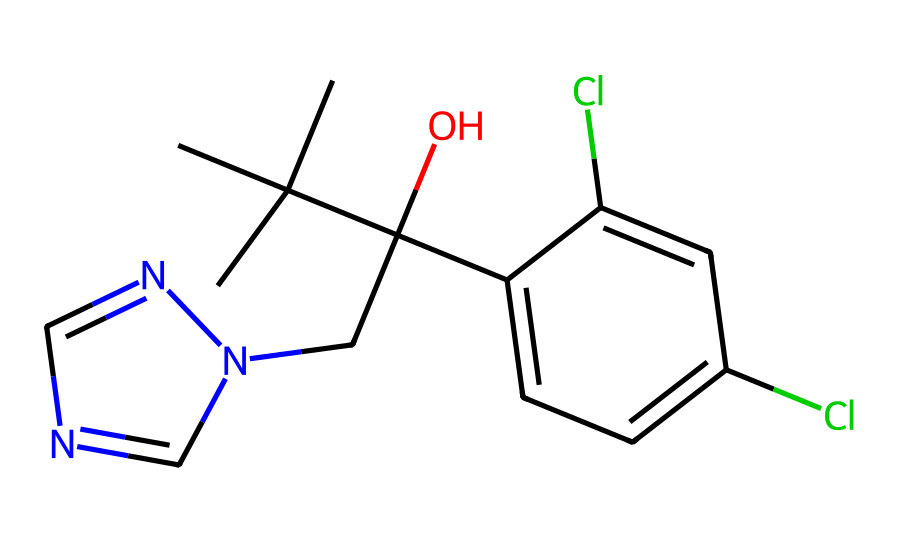What is the main functional group in this compound? In the provided chemical structure, the alcohol group (-OH) attached to the carbon chain is the primary functional group identified within the molecule, which indicates its role in chemical reactivity.
Answer: alcohol How many chlorine atoms are present in the structure? By examining the chemical structure, there are two distinct chlorine (Cl) substituents attached to the aromatic ring, which can be counted directly from the representation.
Answer: two What is the total number of nitrogen atoms in the chemical? Observing the structure shows there are two nitrogen (N) atoms existing within the five-membered ring, specifically contributing to the overall heterocyclic framework of the compound, allowing for proper counting.
Answer: two Is this compound likely to be water-soluble? The presence of both the hydroxyl (-OH) group and the nitrogen atoms generally suggests that the compound could form hydrogen bonds with water, indicating a likelihood of water solubility.
Answer: likely Which ring system is present in this chemical? The compound contains a five-membered ring that consists of nitrogen atoms, which characterizes it as a nitrogen-containing heterocycle. This specific structure can therefore be named the imidazole ring.
Answer: imidazole What type of activity does this compound have against fungi? As a fungicide, the compound is specifically designed to inhibit the growth of fungal organisms and this action is attributed to its chemical nature and functional groups which interact with fungal pathways.
Answer: fungicidal Which atoms in the structure contribute to its overall hydrophobic characteristics? The long carbon chain and the non-polar aromatic ring sections contribute to hydrophobic characteristics, providing a contrast to the polar functional groups present, which remain localized to the molecule's surface.
Answer: carbon chain 